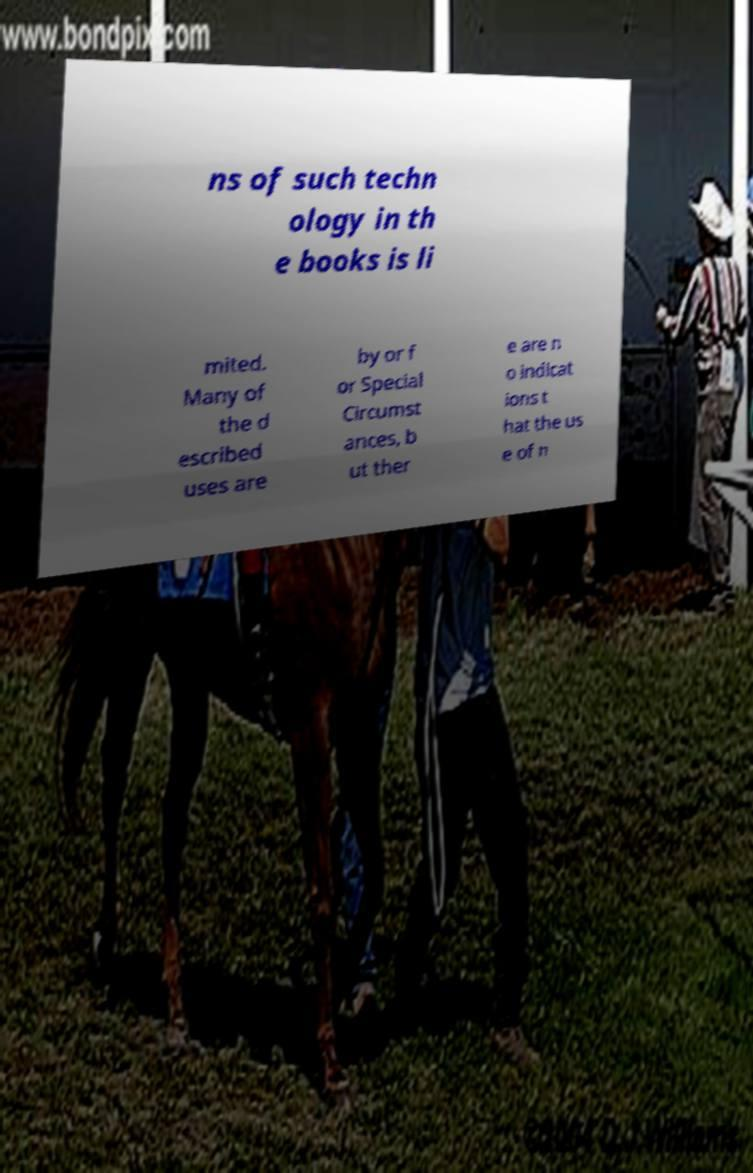What messages or text are displayed in this image? I need them in a readable, typed format. ns of such techn ology in th e books is li mited. Many of the d escribed uses are by or f or Special Circumst ances, b ut ther e are n o indicat ions t hat the us e of n 